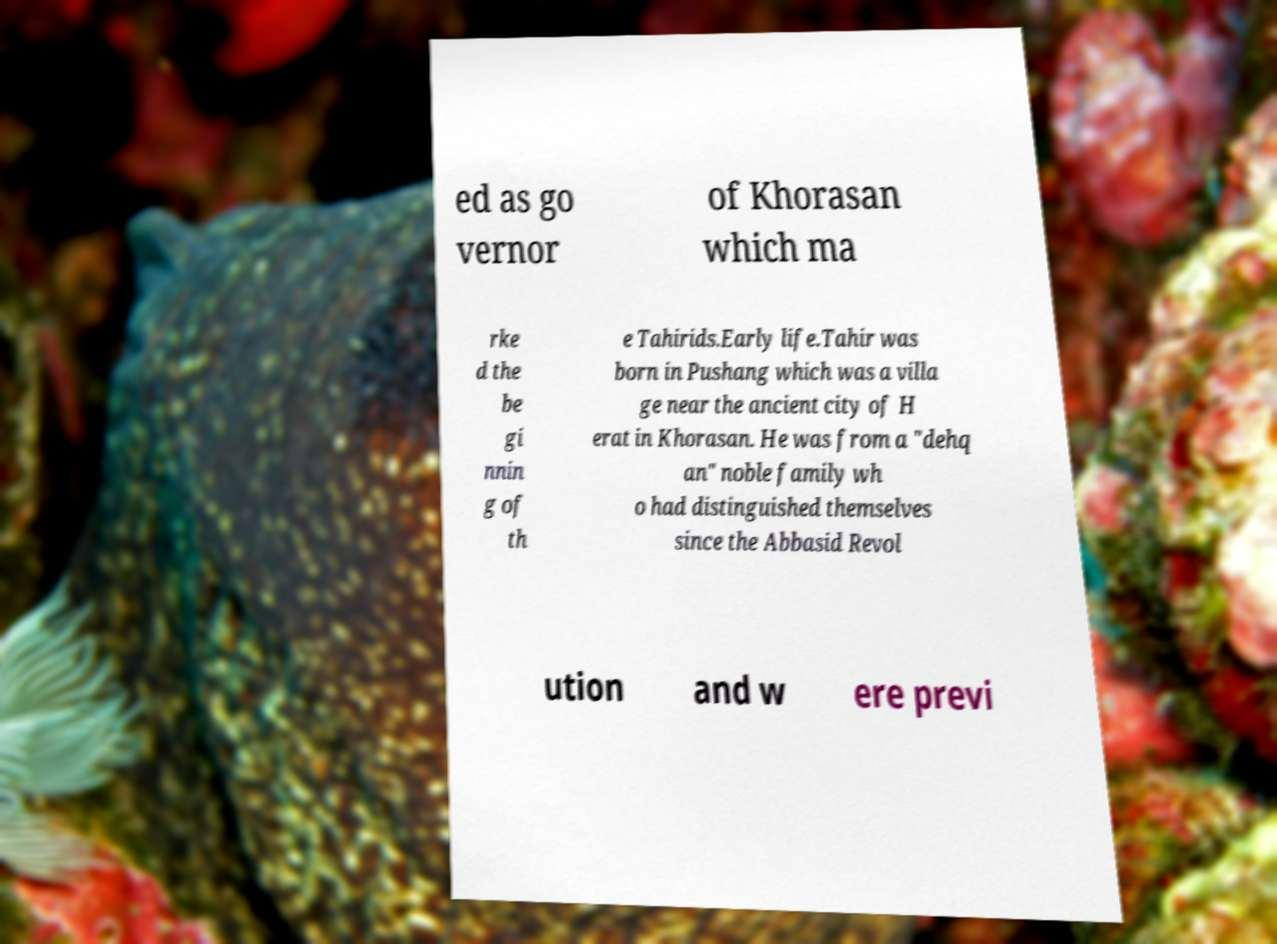What messages or text are displayed in this image? I need them in a readable, typed format. ed as go vernor of Khorasan which ma rke d the be gi nnin g of th e Tahirids.Early life.Tahir was born in Pushang which was a villa ge near the ancient city of H erat in Khorasan. He was from a "dehq an" noble family wh o had distinguished themselves since the Abbasid Revol ution and w ere previ 